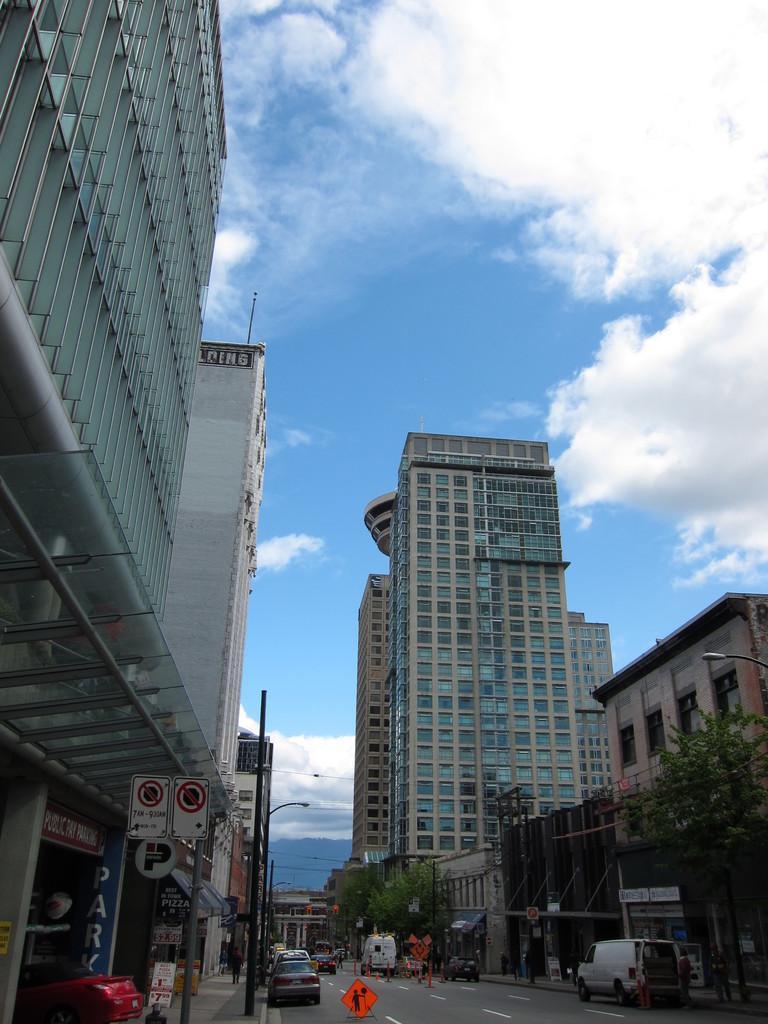Can you describe this image briefly? In this image we can see group of vehicles and traffic cones placed on the road. In the background, we can see a group of buildings, trees, sign boards and the cloudy sky. 